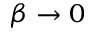<formula> <loc_0><loc_0><loc_500><loc_500>\beta \to 0</formula> 